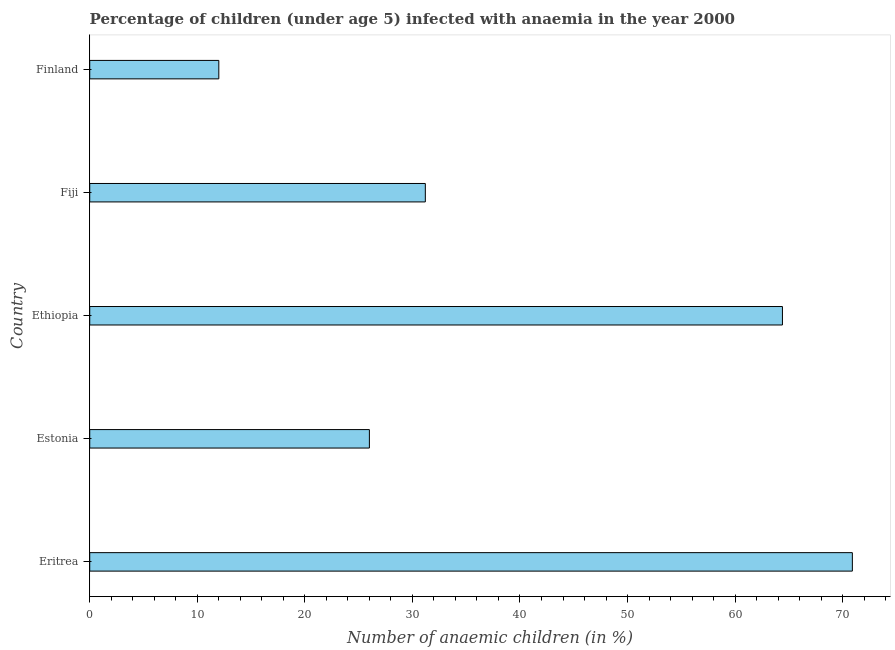Does the graph contain any zero values?
Provide a succinct answer. No. Does the graph contain grids?
Your response must be concise. No. What is the title of the graph?
Offer a very short reply. Percentage of children (under age 5) infected with anaemia in the year 2000. What is the label or title of the X-axis?
Provide a short and direct response. Number of anaemic children (in %). What is the label or title of the Y-axis?
Offer a very short reply. Country. What is the number of anaemic children in Estonia?
Your response must be concise. 26. Across all countries, what is the maximum number of anaemic children?
Provide a succinct answer. 70.9. Across all countries, what is the minimum number of anaemic children?
Provide a short and direct response. 12. In which country was the number of anaemic children maximum?
Your answer should be very brief. Eritrea. What is the sum of the number of anaemic children?
Provide a succinct answer. 204.5. What is the average number of anaemic children per country?
Offer a terse response. 40.9. What is the median number of anaemic children?
Provide a short and direct response. 31.2. What is the ratio of the number of anaemic children in Estonia to that in Finland?
Keep it short and to the point. 2.17. Is the number of anaemic children in Estonia less than that in Fiji?
Provide a short and direct response. Yes. Is the sum of the number of anaemic children in Ethiopia and Finland greater than the maximum number of anaemic children across all countries?
Your answer should be compact. Yes. What is the difference between the highest and the lowest number of anaemic children?
Your response must be concise. 58.9. In how many countries, is the number of anaemic children greater than the average number of anaemic children taken over all countries?
Offer a very short reply. 2. How many bars are there?
Keep it short and to the point. 5. Are all the bars in the graph horizontal?
Your response must be concise. Yes. What is the Number of anaemic children (in %) of Eritrea?
Provide a succinct answer. 70.9. What is the Number of anaemic children (in %) of Ethiopia?
Provide a short and direct response. 64.4. What is the Number of anaemic children (in %) of Fiji?
Ensure brevity in your answer.  31.2. What is the difference between the Number of anaemic children (in %) in Eritrea and Estonia?
Provide a short and direct response. 44.9. What is the difference between the Number of anaemic children (in %) in Eritrea and Ethiopia?
Your response must be concise. 6.5. What is the difference between the Number of anaemic children (in %) in Eritrea and Fiji?
Provide a short and direct response. 39.7. What is the difference between the Number of anaemic children (in %) in Eritrea and Finland?
Provide a short and direct response. 58.9. What is the difference between the Number of anaemic children (in %) in Estonia and Ethiopia?
Provide a short and direct response. -38.4. What is the difference between the Number of anaemic children (in %) in Estonia and Fiji?
Give a very brief answer. -5.2. What is the difference between the Number of anaemic children (in %) in Ethiopia and Fiji?
Give a very brief answer. 33.2. What is the difference between the Number of anaemic children (in %) in Ethiopia and Finland?
Your response must be concise. 52.4. What is the difference between the Number of anaemic children (in %) in Fiji and Finland?
Your answer should be very brief. 19.2. What is the ratio of the Number of anaemic children (in %) in Eritrea to that in Estonia?
Provide a succinct answer. 2.73. What is the ratio of the Number of anaemic children (in %) in Eritrea to that in Ethiopia?
Give a very brief answer. 1.1. What is the ratio of the Number of anaemic children (in %) in Eritrea to that in Fiji?
Ensure brevity in your answer.  2.27. What is the ratio of the Number of anaemic children (in %) in Eritrea to that in Finland?
Provide a short and direct response. 5.91. What is the ratio of the Number of anaemic children (in %) in Estonia to that in Ethiopia?
Your response must be concise. 0.4. What is the ratio of the Number of anaemic children (in %) in Estonia to that in Fiji?
Provide a short and direct response. 0.83. What is the ratio of the Number of anaemic children (in %) in Estonia to that in Finland?
Your answer should be compact. 2.17. What is the ratio of the Number of anaemic children (in %) in Ethiopia to that in Fiji?
Provide a short and direct response. 2.06. What is the ratio of the Number of anaemic children (in %) in Ethiopia to that in Finland?
Your response must be concise. 5.37. 